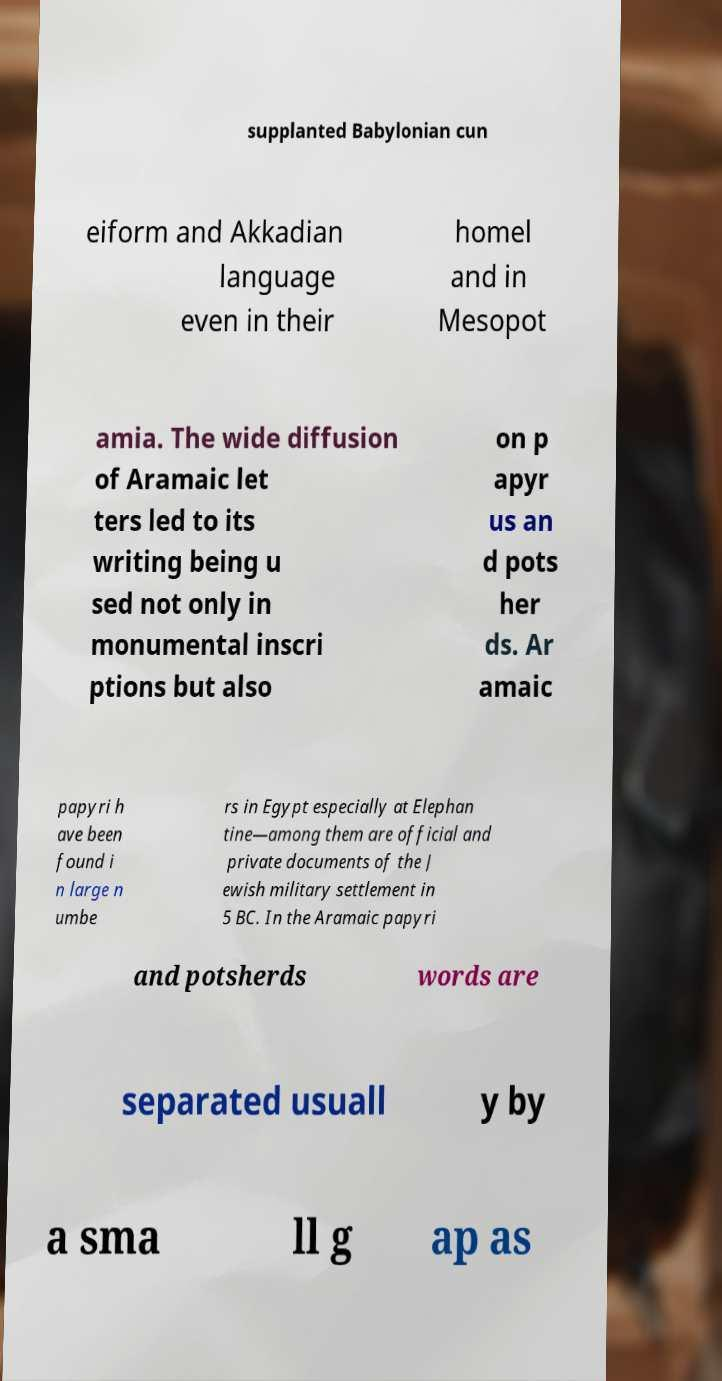Can you read and provide the text displayed in the image?This photo seems to have some interesting text. Can you extract and type it out for me? supplanted Babylonian cun eiform and Akkadian language even in their homel and in Mesopot amia. The wide diffusion of Aramaic let ters led to its writing being u sed not only in monumental inscri ptions but also on p apyr us an d pots her ds. Ar amaic papyri h ave been found i n large n umbe rs in Egypt especially at Elephan tine—among them are official and private documents of the J ewish military settlement in 5 BC. In the Aramaic papyri and potsherds words are separated usuall y by a sma ll g ap as 